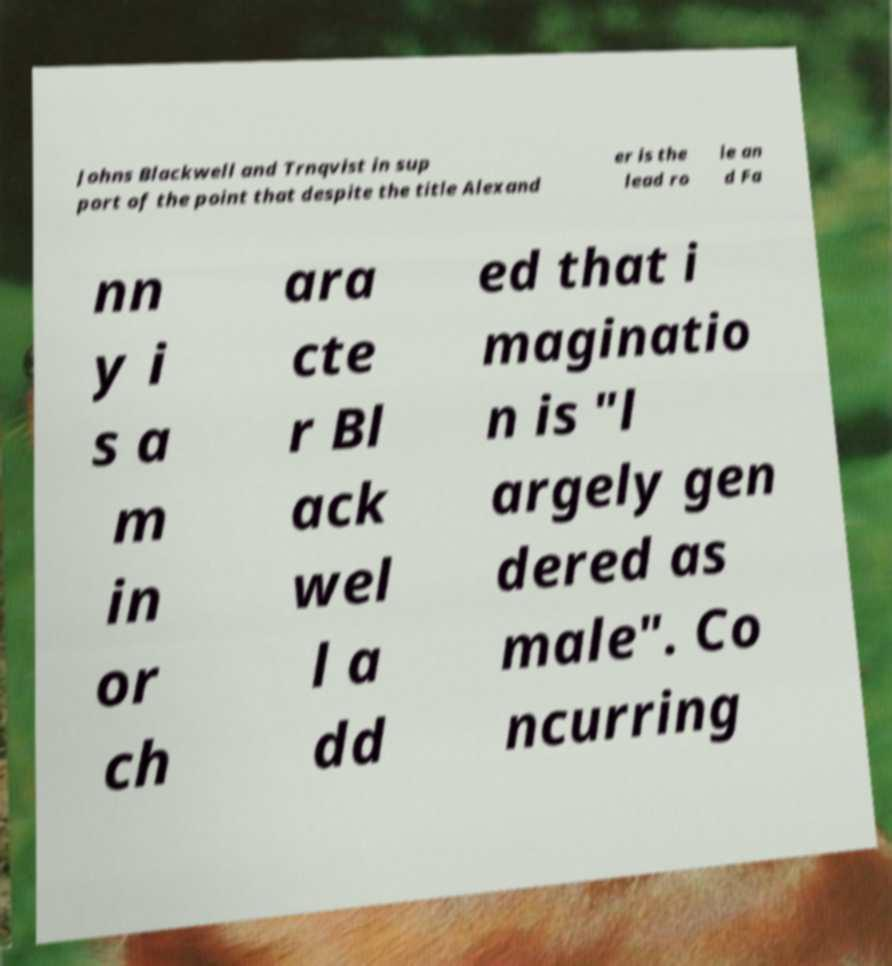There's text embedded in this image that I need extracted. Can you transcribe it verbatim? Johns Blackwell and Trnqvist in sup port of the point that despite the title Alexand er is the lead ro le an d Fa nn y i s a m in or ch ara cte r Bl ack wel l a dd ed that i maginatio n is "l argely gen dered as male". Co ncurring 